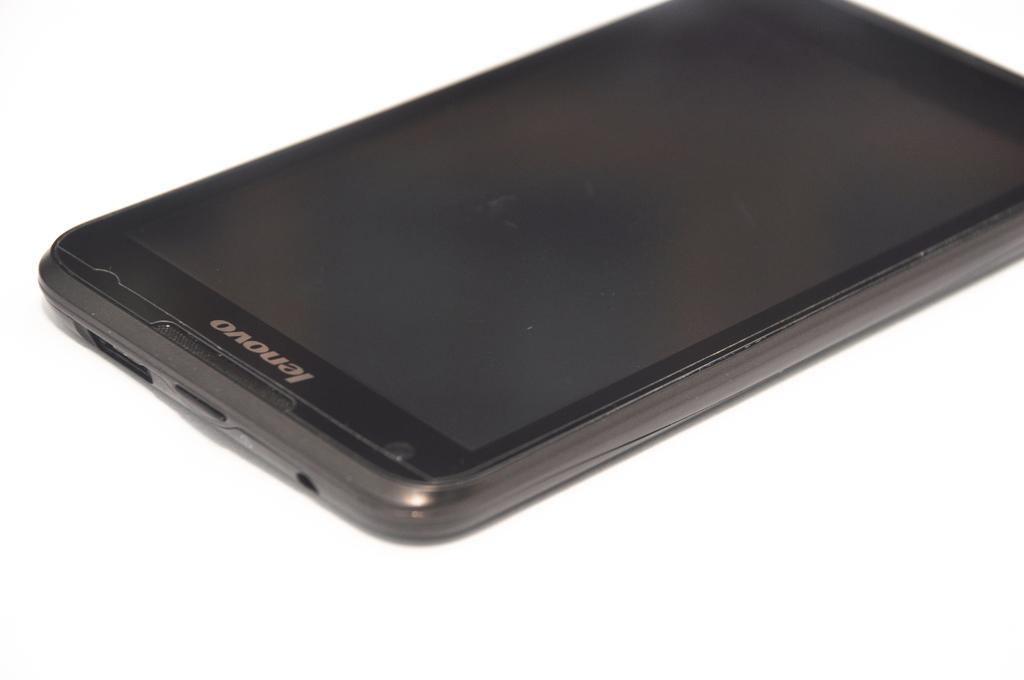<image>
Share a concise interpretation of the image provided. a black lenovo cell phone laying flat with screen off 